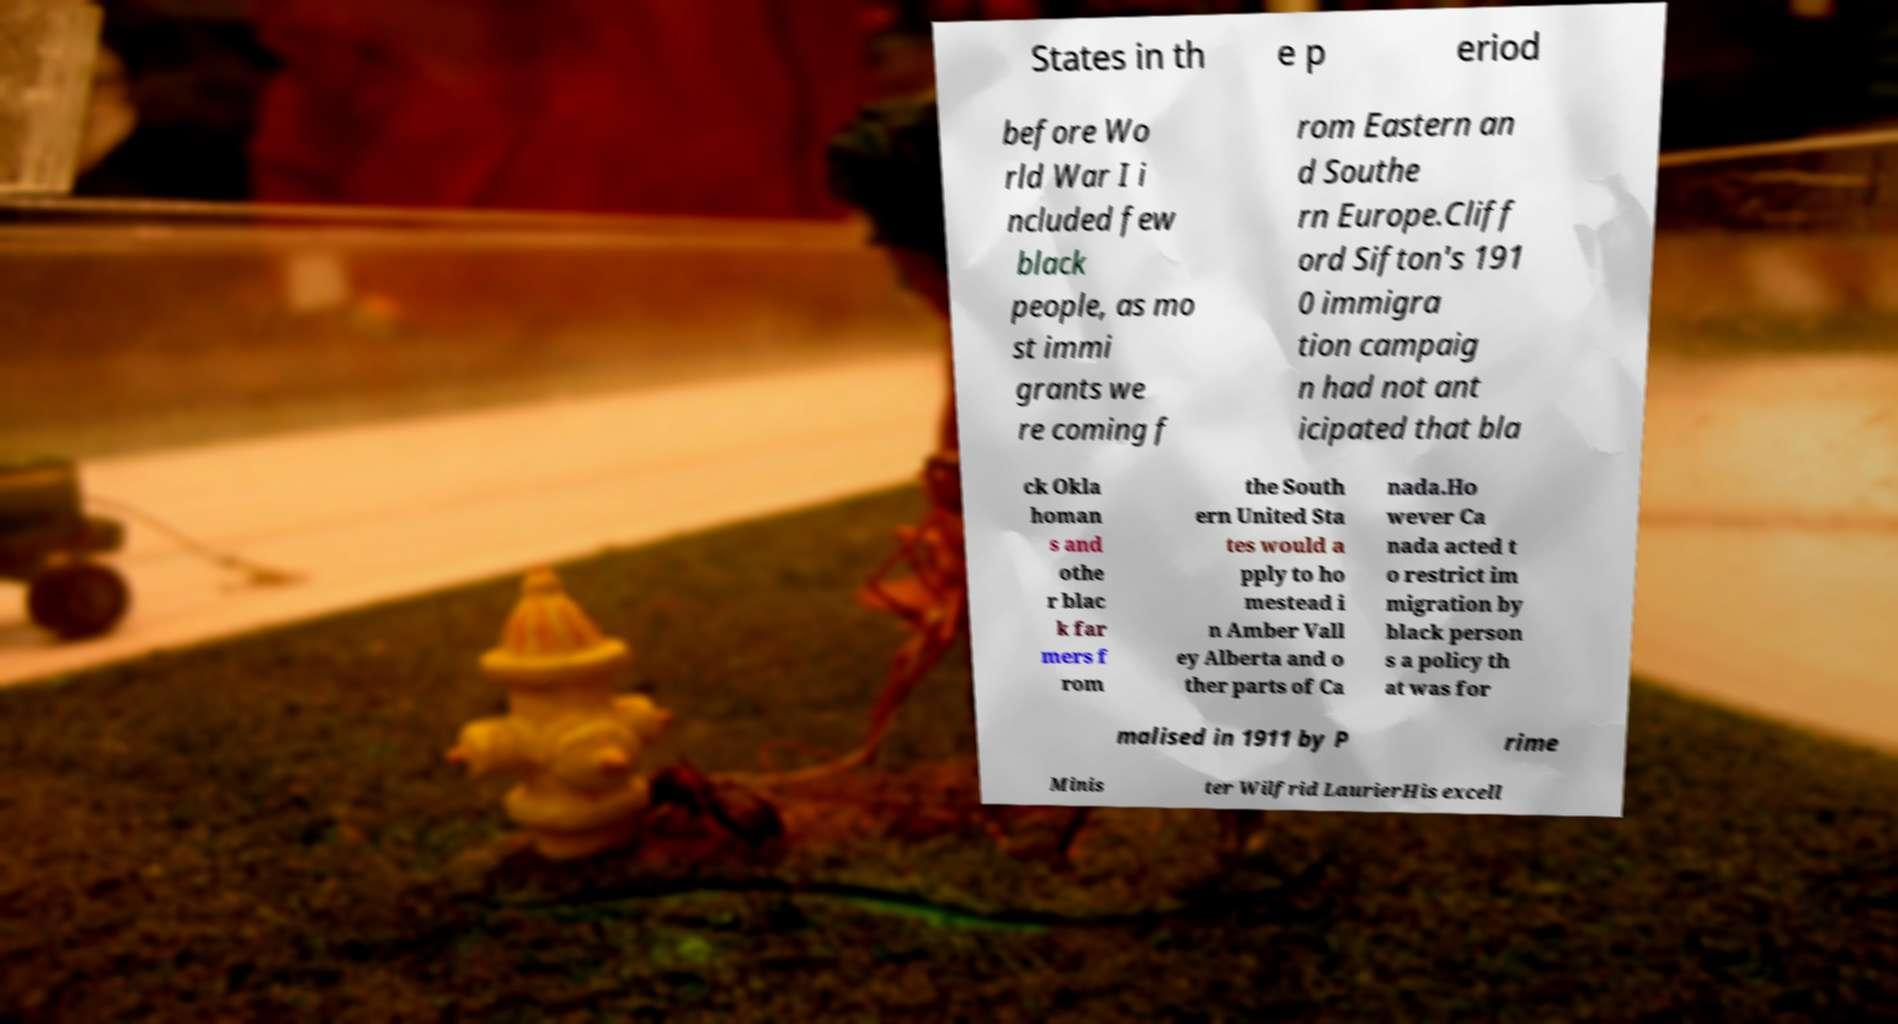Could you assist in decoding the text presented in this image and type it out clearly? States in th e p eriod before Wo rld War I i ncluded few black people, as mo st immi grants we re coming f rom Eastern an d Southe rn Europe.Cliff ord Sifton's 191 0 immigra tion campaig n had not ant icipated that bla ck Okla homan s and othe r blac k far mers f rom the South ern United Sta tes would a pply to ho mestead i n Amber Vall ey Alberta and o ther parts of Ca nada.Ho wever Ca nada acted t o restrict im migration by black person s a policy th at was for malised in 1911 by P rime Minis ter Wilfrid LaurierHis excell 